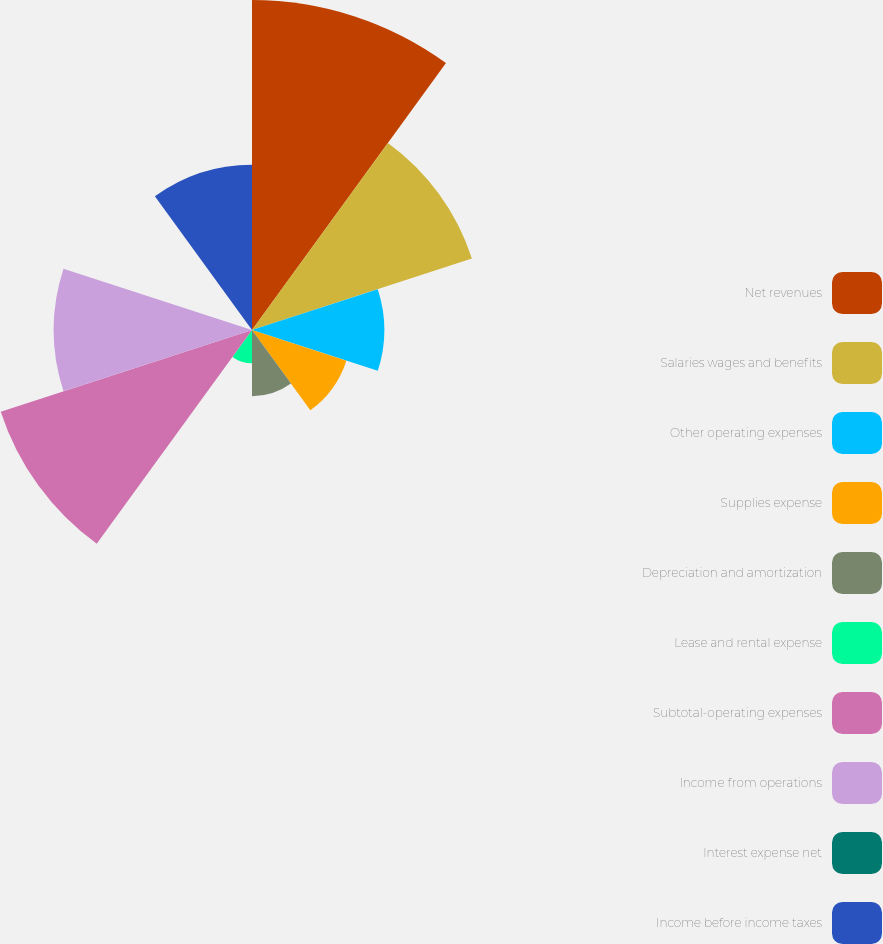<chart> <loc_0><loc_0><loc_500><loc_500><pie_chart><fcel>Net revenues<fcel>Salaries wages and benefits<fcel>Other operating expenses<fcel>Supplies expense<fcel>Depreciation and amortization<fcel>Lease and rental expense<fcel>Subtotal-operating expenses<fcel>Income from operations<fcel>Interest expense net<fcel>Income before income taxes<nl><fcel>21.71%<fcel>15.21%<fcel>8.7%<fcel>6.53%<fcel>4.36%<fcel>2.19%<fcel>17.38%<fcel>13.04%<fcel>0.02%<fcel>10.87%<nl></chart> 